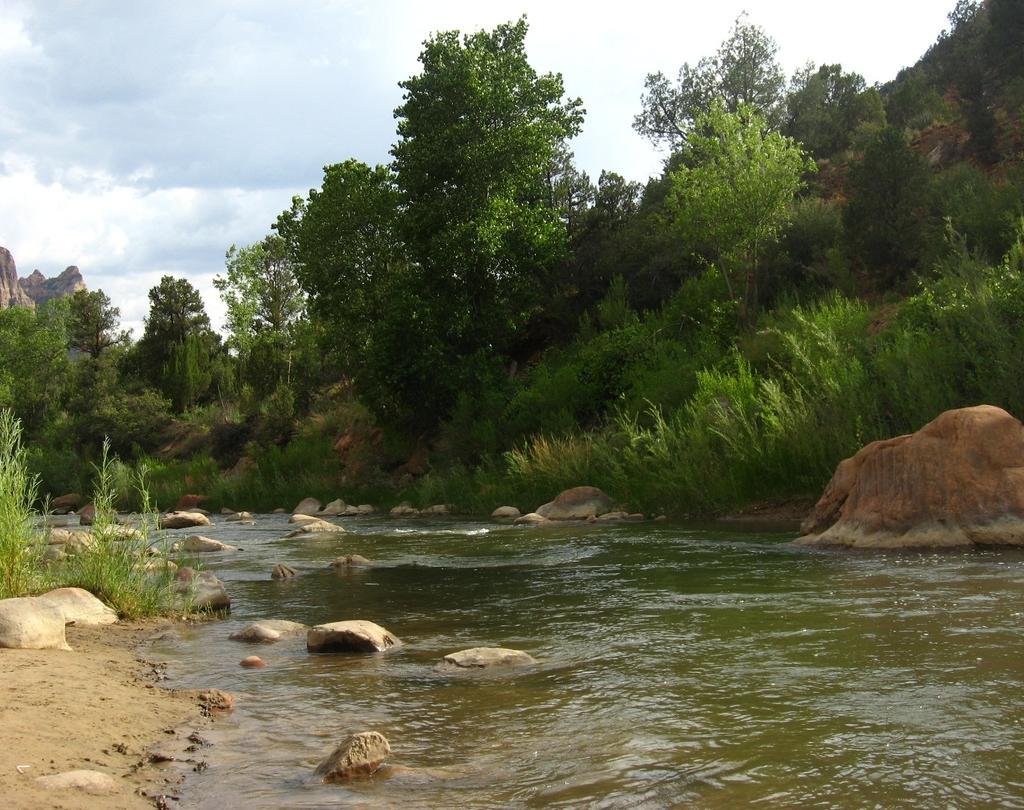Describe this image in one or two sentences. In this picture we can see there are stones, water, plants, trees, hills and a sky. 